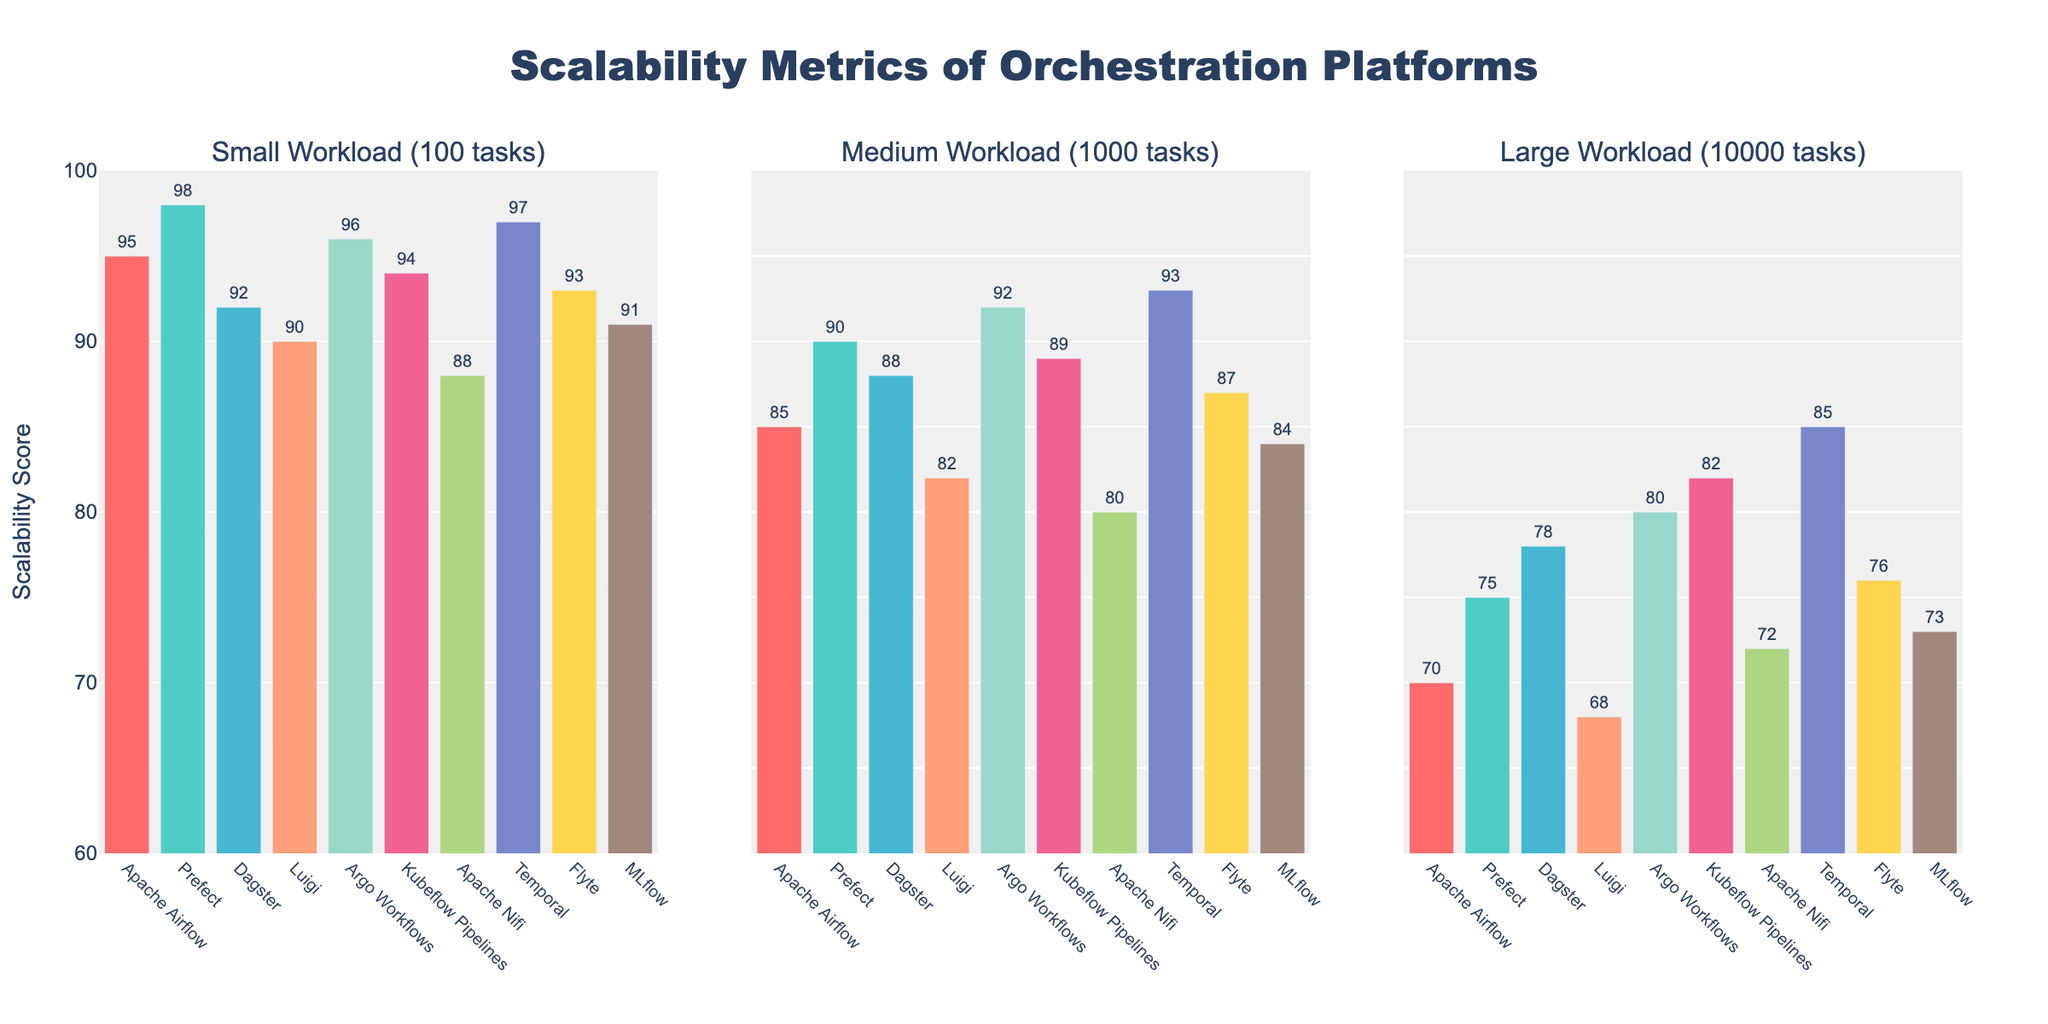What is the title of the figure? The title of the figure is prominently displayed at the top of the figure.
Answer: Scalability Metrics of Orchestration Platforms How many workload sizes are represented in the figure? The figure has three subplots, each representing a different workload size as per the subplot titles.
Answer: Three Which orchestration platform has the highest scalability score for a small workload? By examining the "Small Workload" subplot, we can see that Temporal has the highest bar.
Answer: Temporal Which orchestration platform shows the most consistent performance across all workload sizes? To determine consistency, we observe the fluctuation between scores. Temporal has minimal changes: 97 in small, 93 in medium, and 85 in large workload sizes.
Answer: Temporal What is the color of the bar representing Prefect in the medium workload subplot? By looking at the medium workload subplot, we find that Prefect's bar is colored in turquoise.
Answer: Turquoise What is the average scalability score of Apache Airflow across all workload sizes? The values for Apache Airflow are 95, 85, and 70. Adding these and dividing by 3 gives (95+85+70)/3.
Answer: 83.33 What is the difference in scalability scores between the small and large workloads for Flyte? Flyte's scores are 93 (small) and 76 (large). The difference is 93 - 76.
Answer: 17 Which platform shows the largest decrease in scalability score from medium to large workload? By comparing the differences from medium to large workload for each platform, Apache Airflow has the largest drop from 85 to 70 (a decrease of 15).
Answer: Apache Airflow Which platforms score above 90 for the medium workload? By examining the medium workload subplot, Prefect, Dagster, Argo Workflows, and Temporal score above 90.
Answer: Prefect, Dagster, Argo Workflows, Temporal How does Apache Nifi's performance for small workload compare to medium workload? Apache Nifi has a score of 88 for small workload and 80 for medium workload. Comparing these, the performance decreases from 88 to 80.
Answer: Decreased 